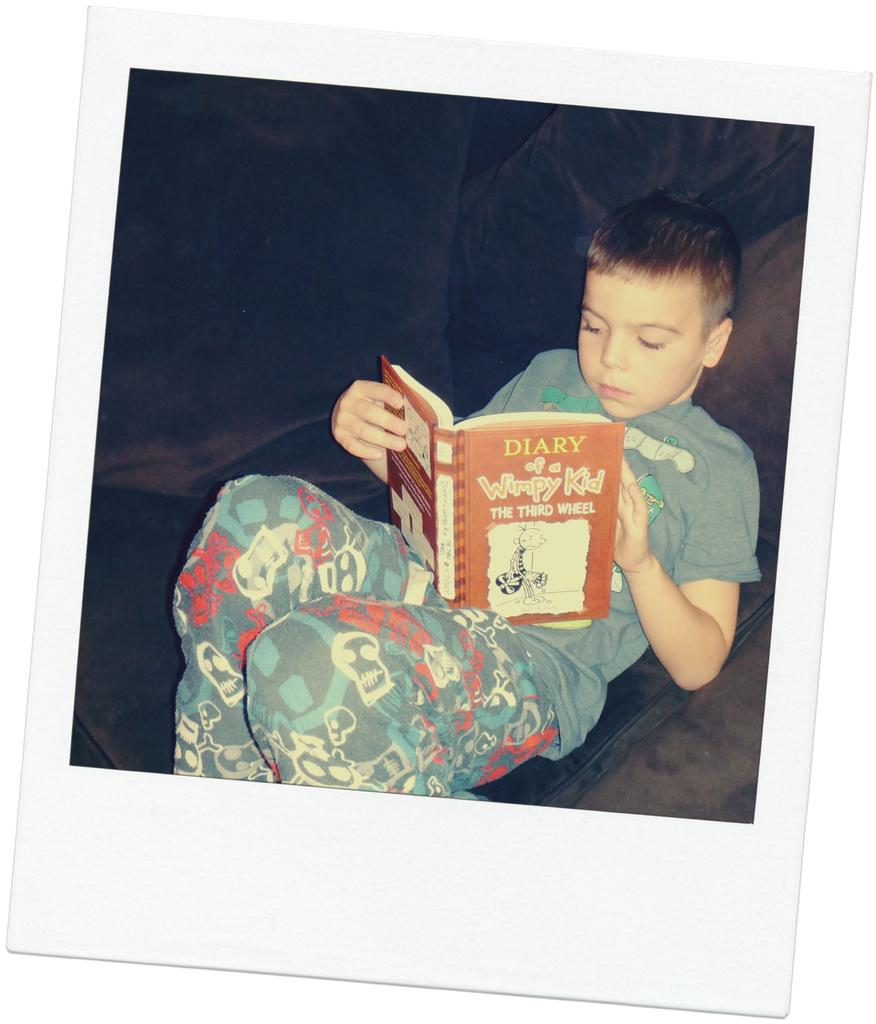<image>
Describe the image concisely. A polaroid picture of a child reading a book titled DIARY of a Wimpy Kid. 